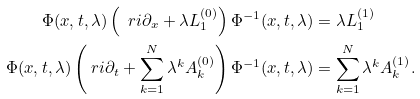<formula> <loc_0><loc_0><loc_500><loc_500>\Phi ( x , t , \lambda ) \left ( \ r i \partial _ { x } + \lambda L _ { 1 } ^ { ( 0 ) } \right ) \Phi ^ { - 1 } ( x , t , \lambda ) & = \lambda L _ { 1 } ^ { ( 1 ) } \\ \Phi ( x , t , \lambda ) \left ( \ r i \partial _ { t } + \sum ^ { N } _ { k = 1 } \lambda ^ { k } A _ { k } ^ { ( 0 ) } \right ) \Phi ^ { - 1 } ( x , t , \lambda ) & = \sum ^ { N } _ { k = 1 } \lambda ^ { k } A _ { k } ^ { ( 1 ) } .</formula> 